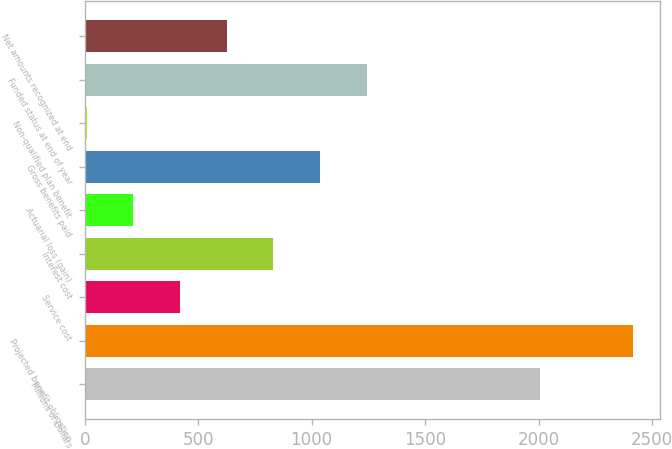Convert chart to OTSL. <chart><loc_0><loc_0><loc_500><loc_500><bar_chart><fcel>Millions of Dollars<fcel>Projected benefit obligation<fcel>Service cost<fcel>Interest cost<fcel>Actuarial loss (gain)<fcel>Gross benefits paid<fcel>Non-qualified plan benefit<fcel>Funded status at end of year<fcel>Net amounts recognized at end<nl><fcel>2005<fcel>2416.2<fcel>420.2<fcel>831.4<fcel>214.6<fcel>1037<fcel>9<fcel>1242.6<fcel>625.8<nl></chart> 